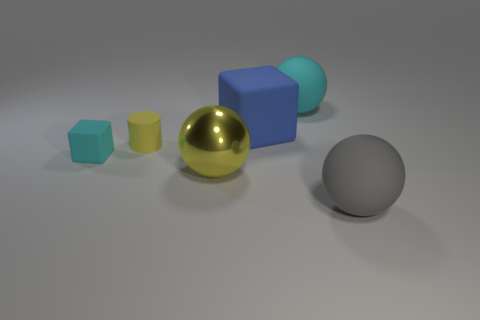There is a cylinder that is the same color as the metal object; what is its size?
Your answer should be compact. Small. How many big objects are either purple spheres or shiny objects?
Give a very brief answer. 1. What number of cyan objects are there?
Offer a terse response. 2. Is the number of balls that are right of the gray matte object the same as the number of small rubber cubes in front of the tiny cyan rubber block?
Your answer should be very brief. Yes. There is a gray ball; are there any big yellow objects in front of it?
Make the answer very short. No. What is the color of the large sphere that is in front of the yellow metal ball?
Provide a short and direct response. Gray. The cyan thing that is behind the cyan rubber object that is left of the big cyan rubber thing is made of what material?
Make the answer very short. Rubber. Is the number of big blue rubber things that are to the right of the gray thing less than the number of small matte blocks in front of the small cyan rubber thing?
Your response must be concise. No. What number of cyan things are either tiny metal cubes or rubber things?
Provide a short and direct response. 2. Are there the same number of cyan spheres on the right side of the gray thing and tiny cyan rubber blocks?
Provide a short and direct response. No. 